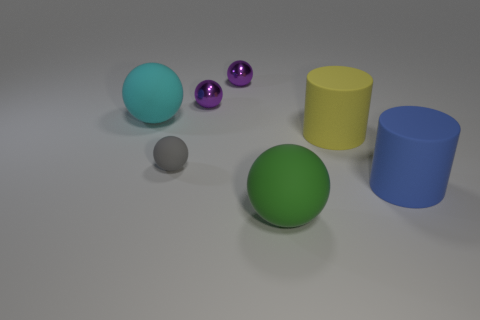Subtract all green cubes. How many purple spheres are left? 2 Subtract all gray rubber balls. How many balls are left? 4 Subtract all green balls. How many balls are left? 4 Add 1 blue rubber things. How many objects exist? 8 Subtract all gray balls. Subtract all purple cylinders. How many balls are left? 4 Subtract all balls. How many objects are left? 2 Subtract 1 yellow cylinders. How many objects are left? 6 Subtract all small yellow rubber balls. Subtract all big green matte balls. How many objects are left? 6 Add 6 small gray things. How many small gray things are left? 7 Add 1 big purple metallic blocks. How many big purple metallic blocks exist? 1 